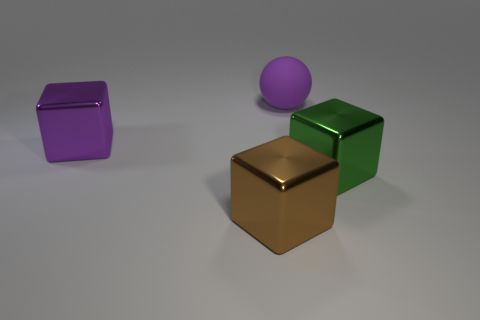Subtract all large purple metal cubes. How many cubes are left? 2 Add 1 tiny purple cylinders. How many objects exist? 5 Subtract all brown cubes. How many cubes are left? 2 Subtract 1 spheres. How many spheres are left? 0 Subtract all big green metal cubes. Subtract all big yellow rubber cylinders. How many objects are left? 3 Add 2 brown metallic blocks. How many brown metallic blocks are left? 3 Add 1 blue objects. How many blue objects exist? 1 Subtract 0 red cubes. How many objects are left? 4 Subtract all blocks. How many objects are left? 1 Subtract all cyan cubes. Subtract all cyan cylinders. How many cubes are left? 3 